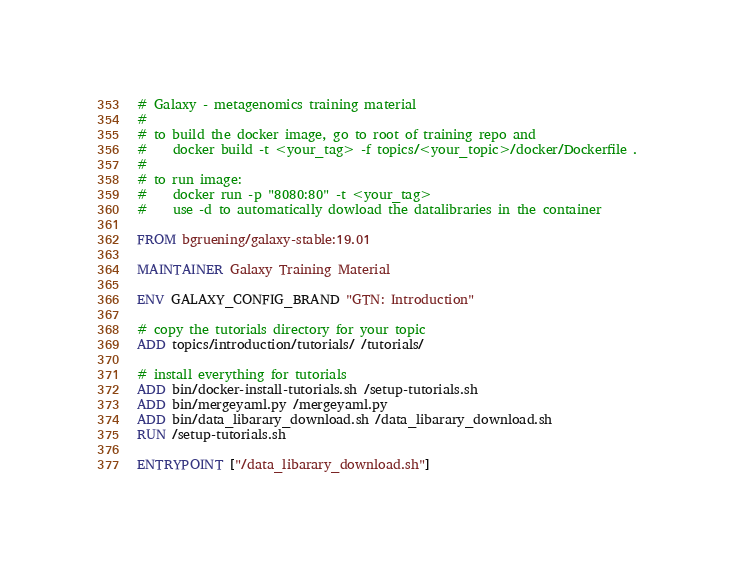<code> <loc_0><loc_0><loc_500><loc_500><_Dockerfile_># Galaxy - metagenomics training material
#
# to build the docker image, go to root of training repo and
#    docker build -t <your_tag> -f topics/<your_topic>/docker/Dockerfile .
#
# to run image:
#    docker run -p "8080:80" -t <your_tag>
#    use -d to automatically dowload the datalibraries in the container

FROM bgruening/galaxy-stable:19.01

MAINTAINER Galaxy Training Material

ENV GALAXY_CONFIG_BRAND "GTN: Introduction"

# copy the tutorials directory for your topic
ADD topics/introduction/tutorials/ /tutorials/

# install everything for tutorials
ADD bin/docker-install-tutorials.sh /setup-tutorials.sh
ADD bin/mergeyaml.py /mergeyaml.py
ADD bin/data_libarary_download.sh /data_libarary_download.sh
RUN /setup-tutorials.sh

ENTRYPOINT ["/data_libarary_download.sh"]</code> 